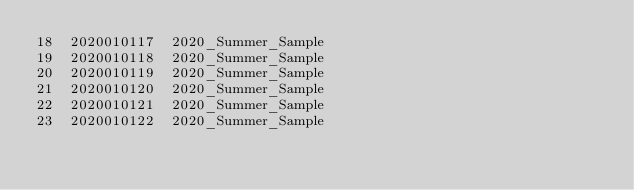<code> <loc_0><loc_0><loc_500><loc_500><_SQL_>18	2020010117	2020_Summer_Sample
19	2020010118	2020_Summer_Sample
20	2020010119	2020_Summer_Sample
21	2020010120	2020_Summer_Sample
22	2020010121	2020_Summer_Sample
23	2020010122	2020_Summer_Sample</code> 